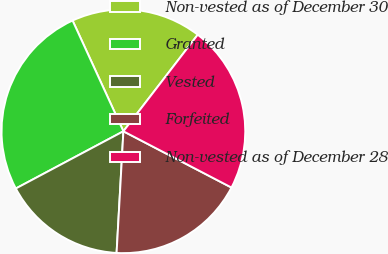Convert chart to OTSL. <chart><loc_0><loc_0><loc_500><loc_500><pie_chart><fcel>Non-vested as of December 30<fcel>Granted<fcel>Vested<fcel>Forfeited<fcel>Non-vested as of December 28<nl><fcel>17.29%<fcel>25.93%<fcel>16.33%<fcel>18.25%<fcel>22.2%<nl></chart> 